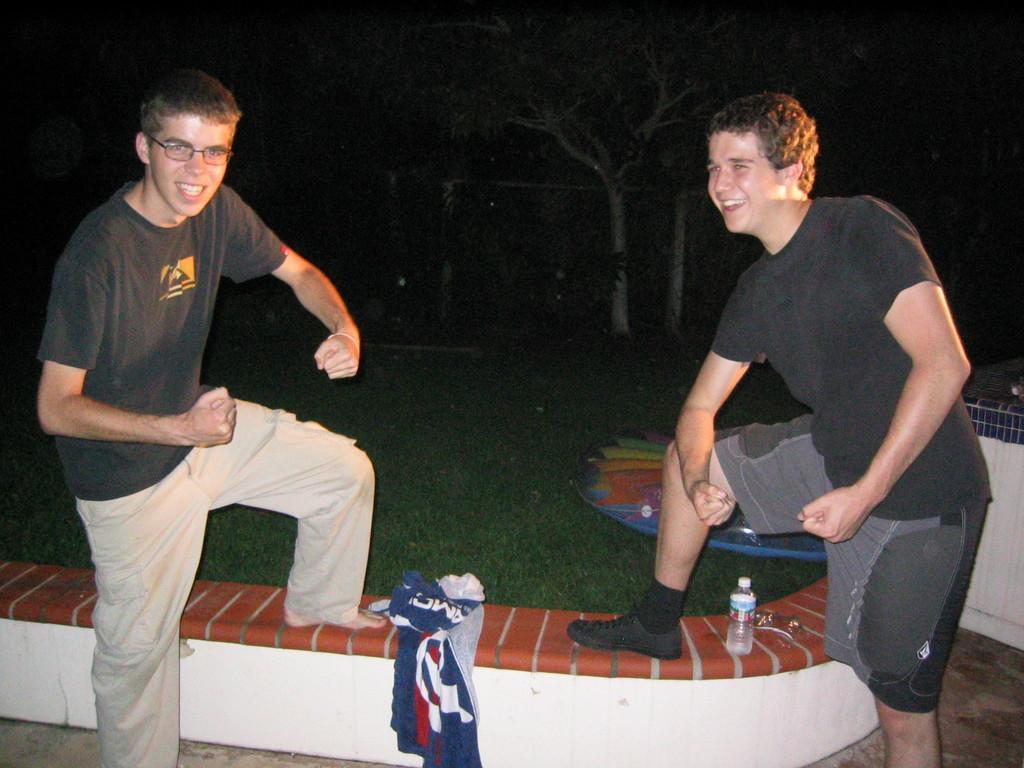Describe this image in one or two sentences. This picture is taken dark. I can see two people bending and posing for the picture. I can see some objects on a divider. I can see some grass and trees.  